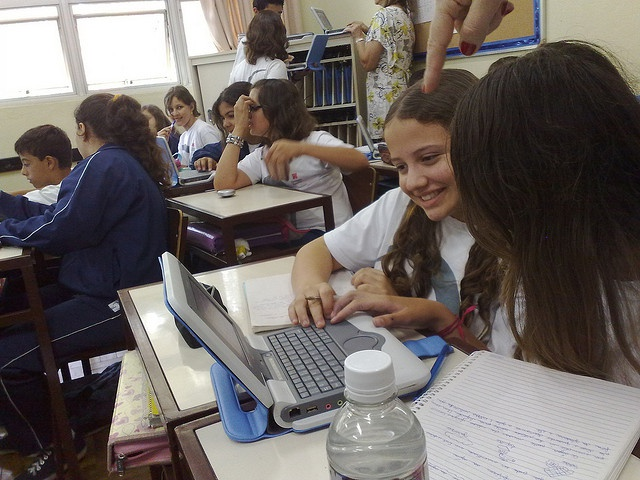Describe the objects in this image and their specific colors. I can see people in lightgray, black, gray, and maroon tones, people in lightgray, black, navy, and gray tones, people in lightgray, black, darkgray, and gray tones, book in lightgray and darkgray tones, and laptop in lightgray, darkgray, gray, and black tones in this image. 